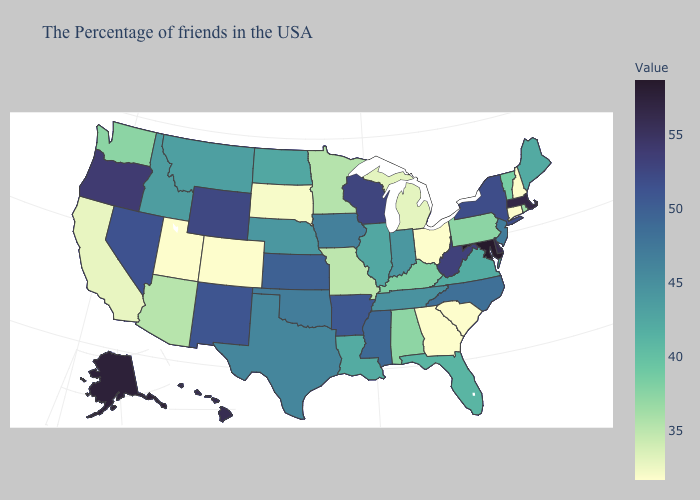Does West Virginia have a lower value than Alaska?
Write a very short answer. Yes. Which states hav the highest value in the West?
Keep it brief. Alaska. Which states have the highest value in the USA?
Quick response, please. Maryland. Is the legend a continuous bar?
Quick response, please. Yes. Does Arkansas have a higher value than Oklahoma?
Keep it brief. Yes. Does North Carolina have the highest value in the South?
Concise answer only. No. Does Maryland have the highest value in the USA?
Be succinct. Yes. 